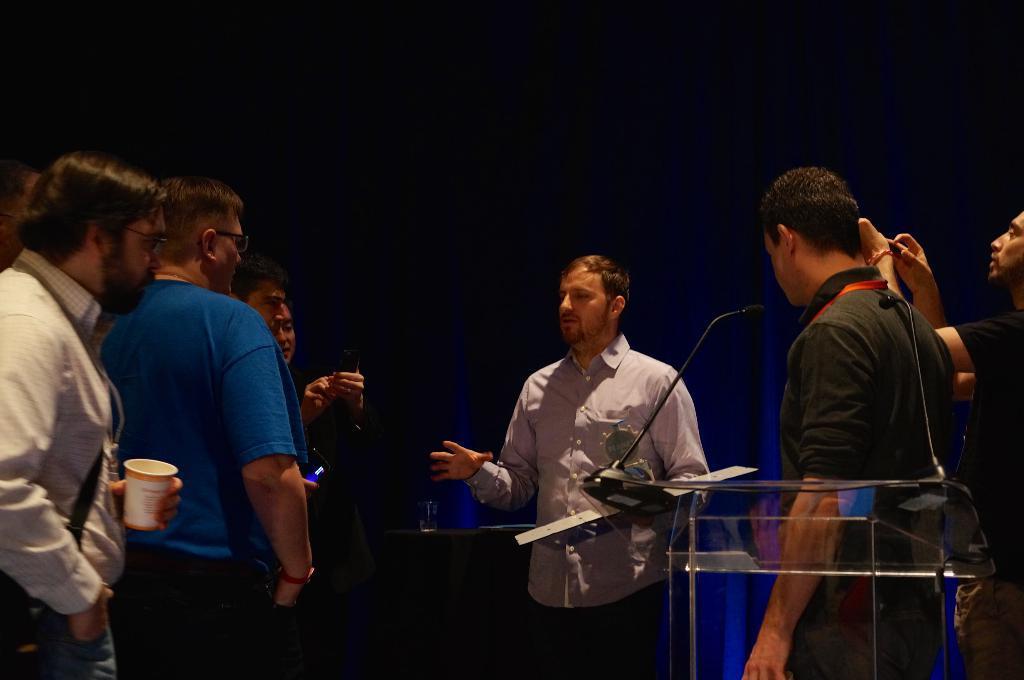How would you summarize this image in a sentence or two? in this image every person has discussing some topic and one person is doing some thing and he is picking the pictures and camera and some instruments are there in the room and the back ground is very dark. 